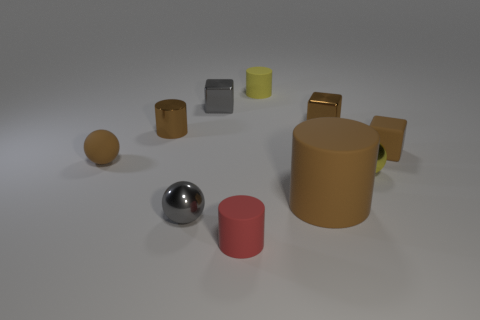There is a cylinder that is to the left of the small yellow rubber cylinder and on the right side of the gray cube; what is its material?
Keep it short and to the point. Rubber. Are there any other things that are the same size as the brown matte cylinder?
Offer a very short reply. No. What number of objects are small yellow shiny balls or small brown rubber blocks?
Offer a very short reply. 2. How many other big objects have the same material as the red thing?
Your response must be concise. 1. Are there fewer tiny metallic spheres than cyan matte balls?
Provide a short and direct response. No. Is the material of the tiny yellow object in front of the rubber block the same as the tiny brown cylinder?
Give a very brief answer. Yes. What number of balls are either tiny yellow shiny objects or red things?
Provide a succinct answer. 1. There is a brown rubber thing that is both behind the brown matte cylinder and right of the small red matte thing; what shape is it?
Make the answer very short. Cube. There is a small cylinder that is in front of the matte thing that is left of the brown shiny thing that is on the left side of the yellow cylinder; what is its color?
Keep it short and to the point. Red. Is the number of yellow cylinders that are behind the gray cube less than the number of brown rubber blocks?
Provide a short and direct response. No. 